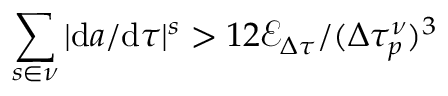Convert formula to latex. <formula><loc_0><loc_0><loc_500><loc_500>\sum _ { s \in \nu } | d a / d \tau | ^ { s } > 1 2 \mathcal { E } _ { \Delta \tau } / ( \Delta \tau _ { p } ^ { \nu } ) ^ { 3 }</formula> 